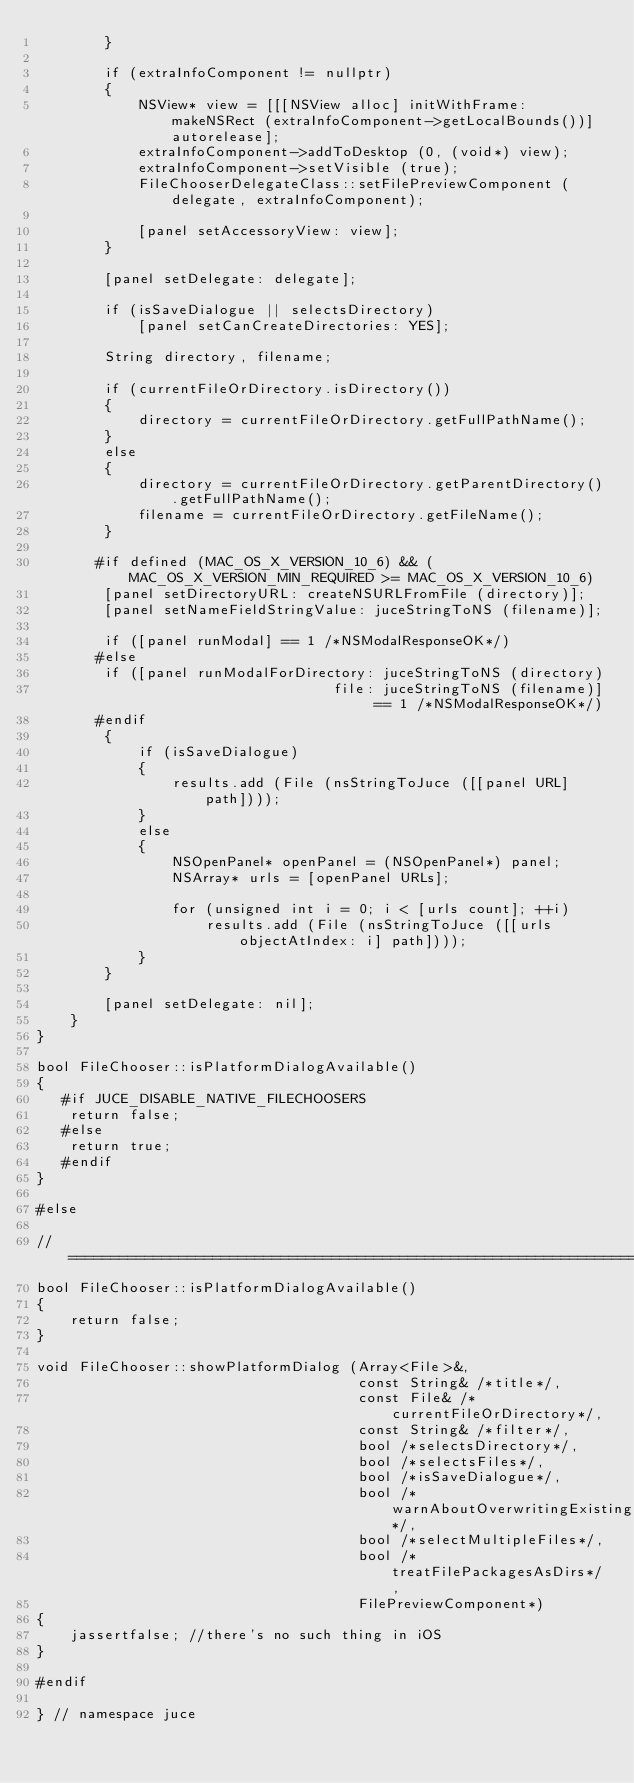Convert code to text. <code><loc_0><loc_0><loc_500><loc_500><_ObjectiveC_>        }

        if (extraInfoComponent != nullptr)
        {
            NSView* view = [[[NSView alloc] initWithFrame: makeNSRect (extraInfoComponent->getLocalBounds())] autorelease];
            extraInfoComponent->addToDesktop (0, (void*) view);
            extraInfoComponent->setVisible (true);
            FileChooserDelegateClass::setFilePreviewComponent (delegate, extraInfoComponent);

            [panel setAccessoryView: view];
        }

        [panel setDelegate: delegate];

        if (isSaveDialogue || selectsDirectory)
            [panel setCanCreateDirectories: YES];

        String directory, filename;

        if (currentFileOrDirectory.isDirectory())
        {
            directory = currentFileOrDirectory.getFullPathName();
        }
        else
        {
            directory = currentFileOrDirectory.getParentDirectory().getFullPathName();
            filename = currentFileOrDirectory.getFileName();
        }

       #if defined (MAC_OS_X_VERSION_10_6) && (MAC_OS_X_VERSION_MIN_REQUIRED >= MAC_OS_X_VERSION_10_6)
        [panel setDirectoryURL: createNSURLFromFile (directory)];
        [panel setNameFieldStringValue: juceStringToNS (filename)];

        if ([panel runModal] == 1 /*NSModalResponseOK*/)
       #else
        if ([panel runModalForDirectory: juceStringToNS (directory)
                                   file: juceStringToNS (filename)] == 1 /*NSModalResponseOK*/)
       #endif
        {
            if (isSaveDialogue)
            {
                results.add (File (nsStringToJuce ([[panel URL] path])));
            }
            else
            {
                NSOpenPanel* openPanel = (NSOpenPanel*) panel;
                NSArray* urls = [openPanel URLs];

                for (unsigned int i = 0; i < [urls count]; ++i)
                    results.add (File (nsStringToJuce ([[urls objectAtIndex: i] path])));
            }
        }

        [panel setDelegate: nil];
    }
}

bool FileChooser::isPlatformDialogAvailable()
{
   #if JUCE_DISABLE_NATIVE_FILECHOOSERS
    return false;
   #else
    return true;
   #endif
}

#else

//==============================================================================
bool FileChooser::isPlatformDialogAvailable()
{
    return false;
}

void FileChooser::showPlatformDialog (Array<File>&,
                                      const String& /*title*/,
                                      const File& /*currentFileOrDirectory*/,
                                      const String& /*filter*/,
                                      bool /*selectsDirectory*/,
                                      bool /*selectsFiles*/,
                                      bool /*isSaveDialogue*/,
                                      bool /*warnAboutOverwritingExistingFiles*/,
                                      bool /*selectMultipleFiles*/,
                                      bool /*treatFilePackagesAsDirs*/,
                                      FilePreviewComponent*)
{
    jassertfalse; //there's no such thing in iOS
}

#endif

} // namespace juce
</code> 